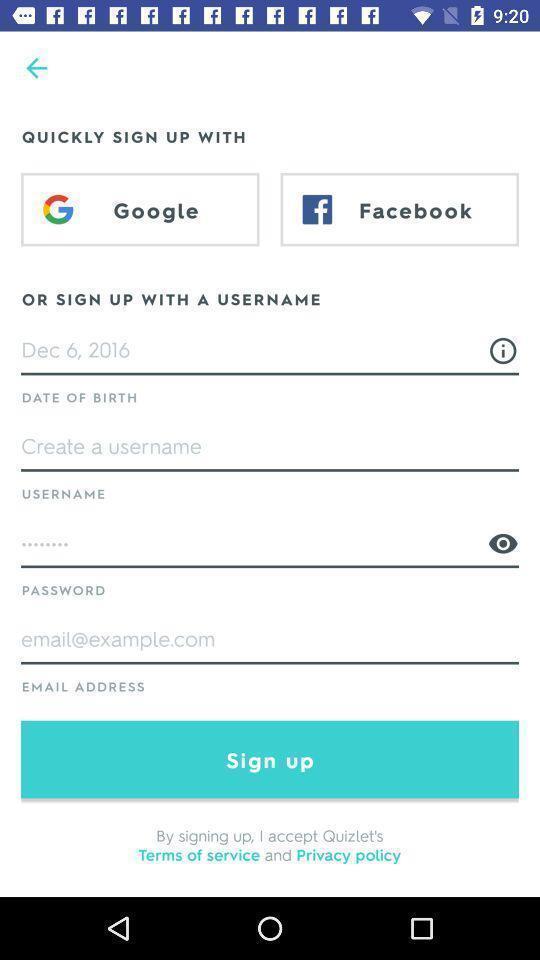What is the overall content of this screenshot? Sign up page of an social app. 